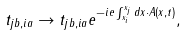<formula> <loc_0><loc_0><loc_500><loc_500>t _ { j b , i a } \rightarrow t _ { j b , i a } e ^ { - i e \int _ { x _ { i } } ^ { x _ { j } } d x \cdot A ( x , t ) } ,</formula> 